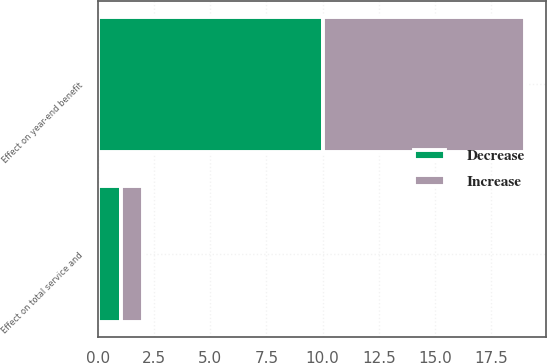Convert chart to OTSL. <chart><loc_0><loc_0><loc_500><loc_500><stacked_bar_chart><ecel><fcel>Effect on total service and<fcel>Effect on year-end benefit<nl><fcel>Decrease<fcel>1<fcel>10<nl><fcel>Increase<fcel>1<fcel>9<nl></chart> 